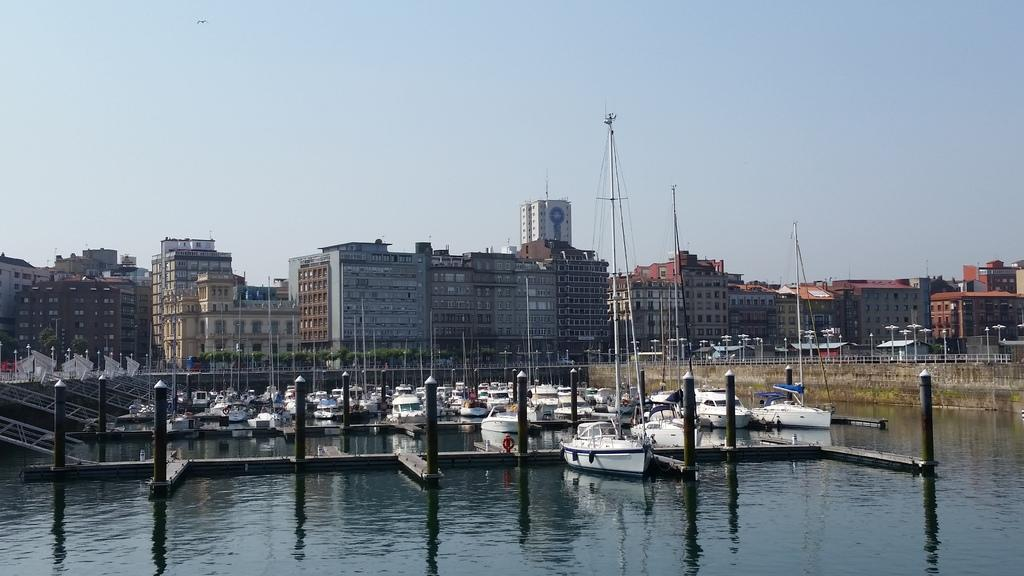What is on the water in the image? There are boats on the water in the image. What structures can be seen in the image? There are buildings, poles, and a wall in the image. What additional features are present in the image? There are lights and a fence in the image. What can be seen in the background of the image? The sky is visible in the background of the image. What type of produce is being harvested in the image? There is no produce present in the image; it features boats on the water, buildings, poles, lights, a fence, a wall, and the sky. What game is being played in the image? There is no game being played in the image; it features boats on the water, buildings, poles, lights, a fence, a wall, and the sky. 